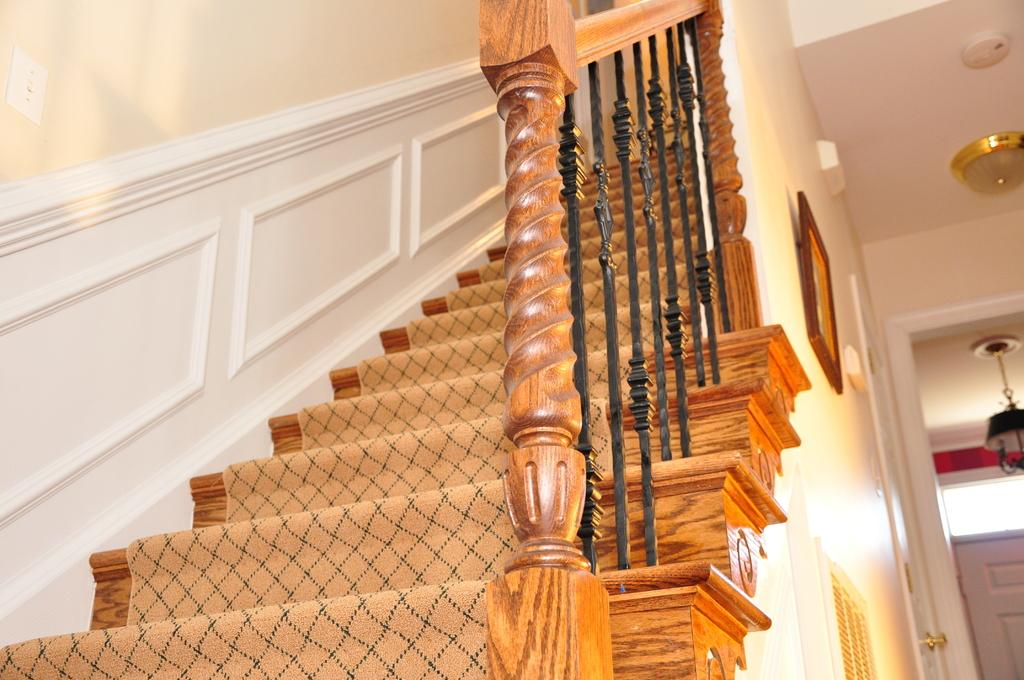What type of architectural feature is present in the image? There is a staircase in the image. What can be seen hanging on the wall in the image? There is a photo frame on the wall. How many doors are visible on the right side of the image? There are two doors on the right side of the image. What type of ice distribution system is present in the image? There is no ice distribution system present in the image. What type of marble is used for the staircase in the image? The image does not provide information about the material used for the staircase. 